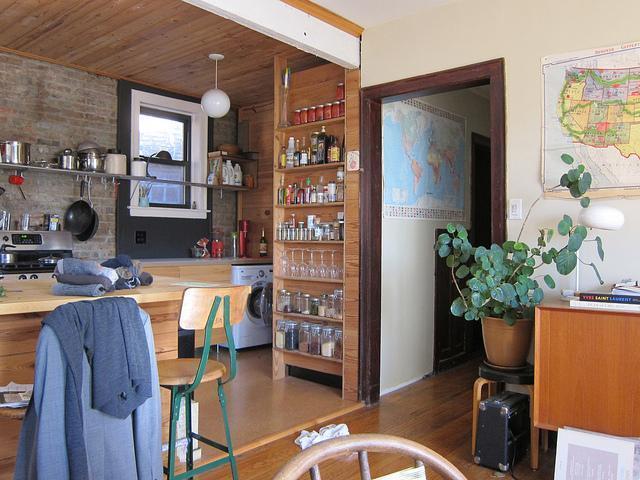How many maps are there?
Give a very brief answer. 2. How many STEMMED glasses are sitting on the shelves?
Give a very brief answer. 6. How many chairs are in the photo?
Give a very brief answer. 3. 